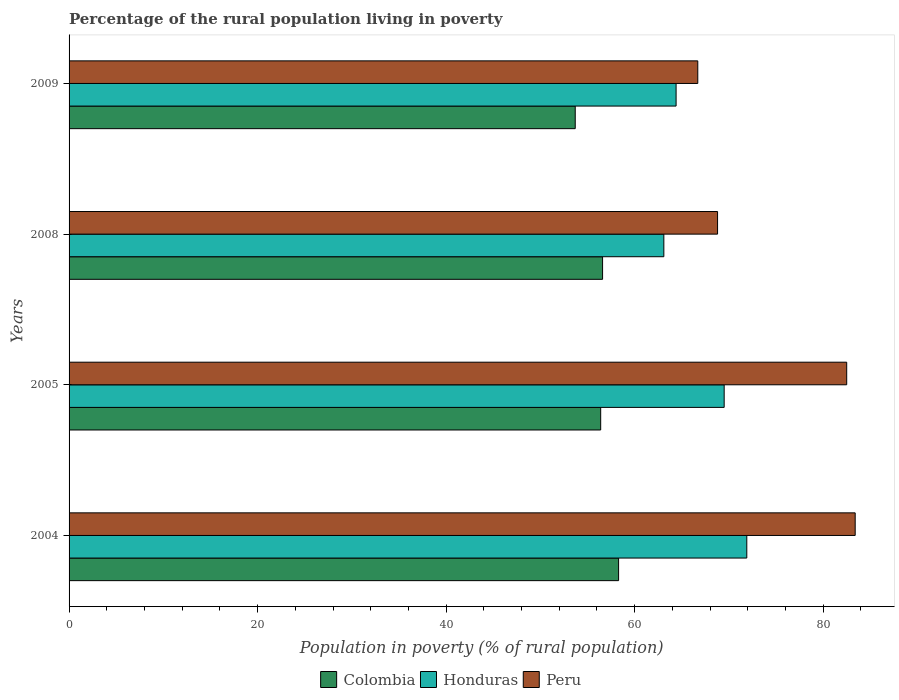How many groups of bars are there?
Provide a short and direct response. 4. Are the number of bars on each tick of the Y-axis equal?
Ensure brevity in your answer.  Yes. What is the label of the 4th group of bars from the top?
Make the answer very short. 2004. What is the percentage of the rural population living in poverty in Colombia in 2009?
Make the answer very short. 53.7. Across all years, what is the maximum percentage of the rural population living in poverty in Colombia?
Your answer should be very brief. 58.3. Across all years, what is the minimum percentage of the rural population living in poverty in Colombia?
Provide a succinct answer. 53.7. In which year was the percentage of the rural population living in poverty in Honduras maximum?
Offer a terse response. 2004. What is the total percentage of the rural population living in poverty in Colombia in the graph?
Your answer should be compact. 225. What is the difference between the percentage of the rural population living in poverty in Colombia in 2004 and that in 2008?
Provide a succinct answer. 1.7. What is the difference between the percentage of the rural population living in poverty in Colombia in 2004 and the percentage of the rural population living in poverty in Honduras in 2009?
Make the answer very short. -6.1. What is the average percentage of the rural population living in poverty in Peru per year?
Provide a short and direct response. 75.35. In the year 2004, what is the difference between the percentage of the rural population living in poverty in Honduras and percentage of the rural population living in poverty in Colombia?
Keep it short and to the point. 13.6. In how many years, is the percentage of the rural population living in poverty in Honduras greater than 20 %?
Your answer should be very brief. 4. What is the ratio of the percentage of the rural population living in poverty in Colombia in 2008 to that in 2009?
Offer a terse response. 1.05. Is the percentage of the rural population living in poverty in Colombia in 2005 less than that in 2008?
Keep it short and to the point. Yes. What is the difference between the highest and the second highest percentage of the rural population living in poverty in Honduras?
Your answer should be compact. 2.4. What is the difference between the highest and the lowest percentage of the rural population living in poverty in Honduras?
Provide a succinct answer. 8.8. In how many years, is the percentage of the rural population living in poverty in Colombia greater than the average percentage of the rural population living in poverty in Colombia taken over all years?
Make the answer very short. 3. What does the 2nd bar from the bottom in 2008 represents?
Offer a very short reply. Honduras. Are all the bars in the graph horizontal?
Your answer should be very brief. Yes. How many years are there in the graph?
Offer a terse response. 4. Are the values on the major ticks of X-axis written in scientific E-notation?
Keep it short and to the point. No. Where does the legend appear in the graph?
Your response must be concise. Bottom center. How are the legend labels stacked?
Keep it short and to the point. Horizontal. What is the title of the graph?
Give a very brief answer. Percentage of the rural population living in poverty. What is the label or title of the X-axis?
Offer a very short reply. Population in poverty (% of rural population). What is the label or title of the Y-axis?
Make the answer very short. Years. What is the Population in poverty (% of rural population) of Colombia in 2004?
Give a very brief answer. 58.3. What is the Population in poverty (% of rural population) of Honduras in 2004?
Provide a short and direct response. 71.9. What is the Population in poverty (% of rural population) of Peru in 2004?
Keep it short and to the point. 83.4. What is the Population in poverty (% of rural population) of Colombia in 2005?
Your answer should be very brief. 56.4. What is the Population in poverty (% of rural population) of Honduras in 2005?
Your response must be concise. 69.5. What is the Population in poverty (% of rural population) of Peru in 2005?
Provide a succinct answer. 82.5. What is the Population in poverty (% of rural population) of Colombia in 2008?
Keep it short and to the point. 56.6. What is the Population in poverty (% of rural population) of Honduras in 2008?
Keep it short and to the point. 63.1. What is the Population in poverty (% of rural population) in Peru in 2008?
Offer a very short reply. 68.8. What is the Population in poverty (% of rural population) of Colombia in 2009?
Your answer should be compact. 53.7. What is the Population in poverty (% of rural population) of Honduras in 2009?
Offer a very short reply. 64.4. What is the Population in poverty (% of rural population) of Peru in 2009?
Provide a succinct answer. 66.7. Across all years, what is the maximum Population in poverty (% of rural population) of Colombia?
Provide a succinct answer. 58.3. Across all years, what is the maximum Population in poverty (% of rural population) in Honduras?
Offer a terse response. 71.9. Across all years, what is the maximum Population in poverty (% of rural population) of Peru?
Ensure brevity in your answer.  83.4. Across all years, what is the minimum Population in poverty (% of rural population) in Colombia?
Offer a very short reply. 53.7. Across all years, what is the minimum Population in poverty (% of rural population) in Honduras?
Your answer should be very brief. 63.1. Across all years, what is the minimum Population in poverty (% of rural population) in Peru?
Provide a short and direct response. 66.7. What is the total Population in poverty (% of rural population) in Colombia in the graph?
Your response must be concise. 225. What is the total Population in poverty (% of rural population) of Honduras in the graph?
Make the answer very short. 268.9. What is the total Population in poverty (% of rural population) of Peru in the graph?
Provide a short and direct response. 301.4. What is the difference between the Population in poverty (% of rural population) in Honduras in 2004 and that in 2005?
Provide a succinct answer. 2.4. What is the difference between the Population in poverty (% of rural population) in Peru in 2004 and that in 2005?
Offer a terse response. 0.9. What is the difference between the Population in poverty (% of rural population) in Peru in 2005 and that in 2008?
Offer a very short reply. 13.7. What is the difference between the Population in poverty (% of rural population) of Colombia in 2005 and that in 2009?
Your answer should be compact. 2.7. What is the difference between the Population in poverty (% of rural population) in Honduras in 2005 and that in 2009?
Give a very brief answer. 5.1. What is the difference between the Population in poverty (% of rural population) of Peru in 2005 and that in 2009?
Your response must be concise. 15.8. What is the difference between the Population in poverty (% of rural population) of Honduras in 2008 and that in 2009?
Ensure brevity in your answer.  -1.3. What is the difference between the Population in poverty (% of rural population) of Peru in 2008 and that in 2009?
Offer a terse response. 2.1. What is the difference between the Population in poverty (% of rural population) in Colombia in 2004 and the Population in poverty (% of rural population) in Honduras in 2005?
Your answer should be compact. -11.2. What is the difference between the Population in poverty (% of rural population) of Colombia in 2004 and the Population in poverty (% of rural population) of Peru in 2005?
Offer a very short reply. -24.2. What is the difference between the Population in poverty (% of rural population) of Honduras in 2004 and the Population in poverty (% of rural population) of Peru in 2005?
Make the answer very short. -10.6. What is the difference between the Population in poverty (% of rural population) of Honduras in 2004 and the Population in poverty (% of rural population) of Peru in 2008?
Your response must be concise. 3.1. What is the difference between the Population in poverty (% of rural population) of Colombia in 2004 and the Population in poverty (% of rural population) of Honduras in 2009?
Your answer should be very brief. -6.1. What is the difference between the Population in poverty (% of rural population) in Colombia in 2005 and the Population in poverty (% of rural population) in Honduras in 2008?
Your answer should be very brief. -6.7. What is the difference between the Population in poverty (% of rural population) of Colombia in 2005 and the Population in poverty (% of rural population) of Peru in 2008?
Ensure brevity in your answer.  -12.4. What is the difference between the Population in poverty (% of rural population) in Colombia in 2005 and the Population in poverty (% of rural population) in Honduras in 2009?
Ensure brevity in your answer.  -8. What is the difference between the Population in poverty (% of rural population) in Colombia in 2008 and the Population in poverty (% of rural population) in Honduras in 2009?
Your answer should be compact. -7.8. What is the difference between the Population in poverty (% of rural population) in Honduras in 2008 and the Population in poverty (% of rural population) in Peru in 2009?
Keep it short and to the point. -3.6. What is the average Population in poverty (% of rural population) in Colombia per year?
Offer a very short reply. 56.25. What is the average Population in poverty (% of rural population) of Honduras per year?
Your answer should be very brief. 67.22. What is the average Population in poverty (% of rural population) in Peru per year?
Offer a terse response. 75.35. In the year 2004, what is the difference between the Population in poverty (% of rural population) in Colombia and Population in poverty (% of rural population) in Peru?
Make the answer very short. -25.1. In the year 2005, what is the difference between the Population in poverty (% of rural population) in Colombia and Population in poverty (% of rural population) in Peru?
Your answer should be very brief. -26.1. In the year 2008, what is the difference between the Population in poverty (% of rural population) of Colombia and Population in poverty (% of rural population) of Honduras?
Your answer should be very brief. -6.5. In the year 2008, what is the difference between the Population in poverty (% of rural population) in Colombia and Population in poverty (% of rural population) in Peru?
Your answer should be very brief. -12.2. In the year 2009, what is the difference between the Population in poverty (% of rural population) in Colombia and Population in poverty (% of rural population) in Honduras?
Ensure brevity in your answer.  -10.7. In the year 2009, what is the difference between the Population in poverty (% of rural population) in Honduras and Population in poverty (% of rural population) in Peru?
Ensure brevity in your answer.  -2.3. What is the ratio of the Population in poverty (% of rural population) in Colombia in 2004 to that in 2005?
Make the answer very short. 1.03. What is the ratio of the Population in poverty (% of rural population) of Honduras in 2004 to that in 2005?
Your answer should be compact. 1.03. What is the ratio of the Population in poverty (% of rural population) of Peru in 2004 to that in 2005?
Offer a very short reply. 1.01. What is the ratio of the Population in poverty (% of rural population) of Honduras in 2004 to that in 2008?
Your response must be concise. 1.14. What is the ratio of the Population in poverty (% of rural population) in Peru in 2004 to that in 2008?
Provide a short and direct response. 1.21. What is the ratio of the Population in poverty (% of rural population) of Colombia in 2004 to that in 2009?
Offer a terse response. 1.09. What is the ratio of the Population in poverty (% of rural population) of Honduras in 2004 to that in 2009?
Make the answer very short. 1.12. What is the ratio of the Population in poverty (% of rural population) in Peru in 2004 to that in 2009?
Your answer should be compact. 1.25. What is the ratio of the Population in poverty (% of rural population) in Honduras in 2005 to that in 2008?
Provide a short and direct response. 1.1. What is the ratio of the Population in poverty (% of rural population) in Peru in 2005 to that in 2008?
Your response must be concise. 1.2. What is the ratio of the Population in poverty (% of rural population) in Colombia in 2005 to that in 2009?
Offer a very short reply. 1.05. What is the ratio of the Population in poverty (% of rural population) in Honduras in 2005 to that in 2009?
Your answer should be compact. 1.08. What is the ratio of the Population in poverty (% of rural population) of Peru in 2005 to that in 2009?
Your response must be concise. 1.24. What is the ratio of the Population in poverty (% of rural population) of Colombia in 2008 to that in 2009?
Keep it short and to the point. 1.05. What is the ratio of the Population in poverty (% of rural population) in Honduras in 2008 to that in 2009?
Offer a very short reply. 0.98. What is the ratio of the Population in poverty (% of rural population) in Peru in 2008 to that in 2009?
Offer a terse response. 1.03. What is the difference between the highest and the second highest Population in poverty (% of rural population) of Colombia?
Ensure brevity in your answer.  1.7. What is the difference between the highest and the second highest Population in poverty (% of rural population) of Peru?
Offer a very short reply. 0.9. What is the difference between the highest and the lowest Population in poverty (% of rural population) of Peru?
Your response must be concise. 16.7. 